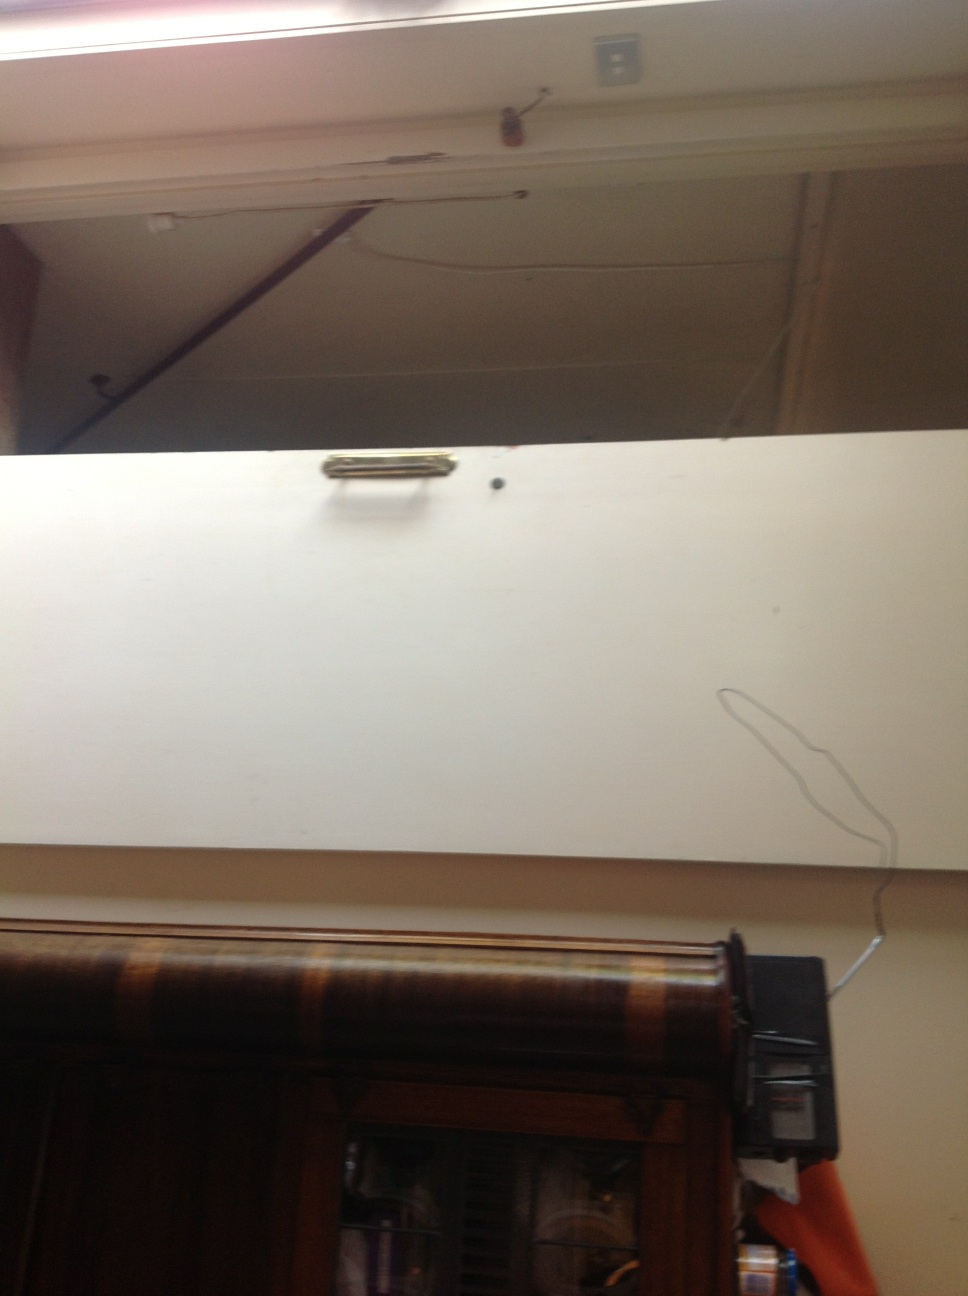Are there any visible signs of wear or damage on the door? Yes, there are signs of wear or possible damage. You can see inconsistencies on the door’s surface including a dark mark on the white area, which might suggest long-term use or minimal maintenance. 